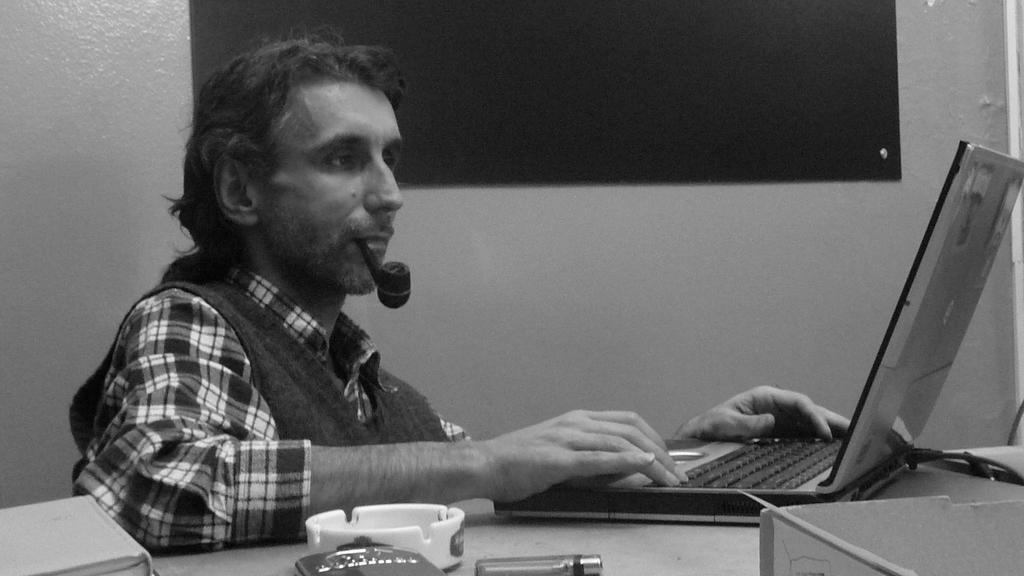Please provide a concise description of this image. In this image a person is sitting. He put a cigar in his mouth. He is using a laptop. In front of him on a table there is ashtray, lighter,bottle, book, laptop. In the background on the wall there is a board. 